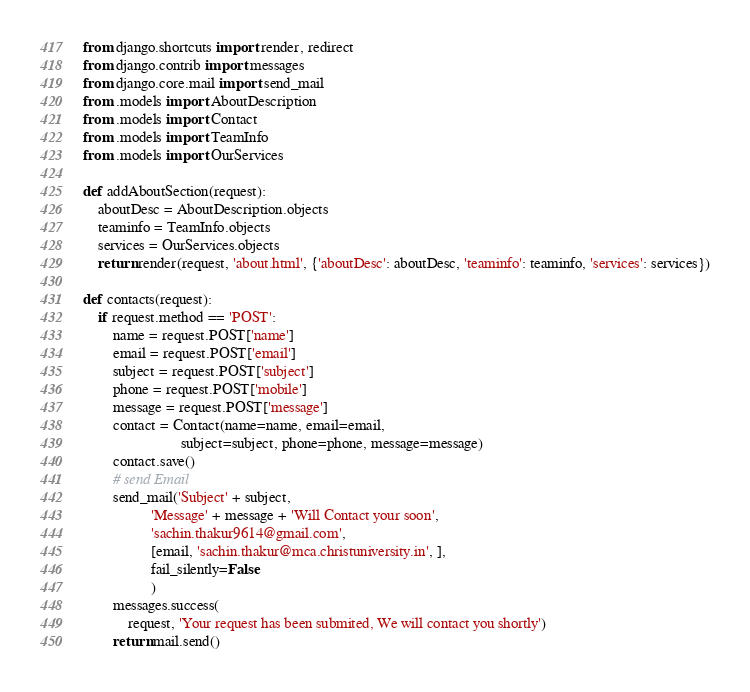Convert code to text. <code><loc_0><loc_0><loc_500><loc_500><_Python_>from django.shortcuts import render, redirect
from django.contrib import messages
from django.core.mail import send_mail
from .models import AboutDescription
from .models import Contact
from .models import TeamInfo
from .models import OurServices

def addAboutSection(request):
    aboutDesc = AboutDescription.objects
    teaminfo = TeamInfo.objects
    services = OurServices.objects
    return render(request, 'about.html', {'aboutDesc': aboutDesc, 'teaminfo': teaminfo, 'services': services})

def contacts(request):
    if request.method == 'POST':
        name = request.POST['name']
        email = request.POST['email']
        subject = request.POST['subject']
        phone = request.POST['mobile']
        message = request.POST['message']
        contact = Contact(name=name, email=email,
                          subject=subject, phone=phone, message=message)
        contact.save()
        # send Email
        send_mail('Subject' + subject,
                  'Message' + message + 'Will Contact your soon',
                  'sachin.thakur9614@gmail.com',
                  [email, 'sachin.thakur@mca.christuniversity.in', ],
                  fail_silently=False
                  )
        messages.success(
            request, 'Your request has been submited, We will contact you shortly')
        return mail.send()
</code> 